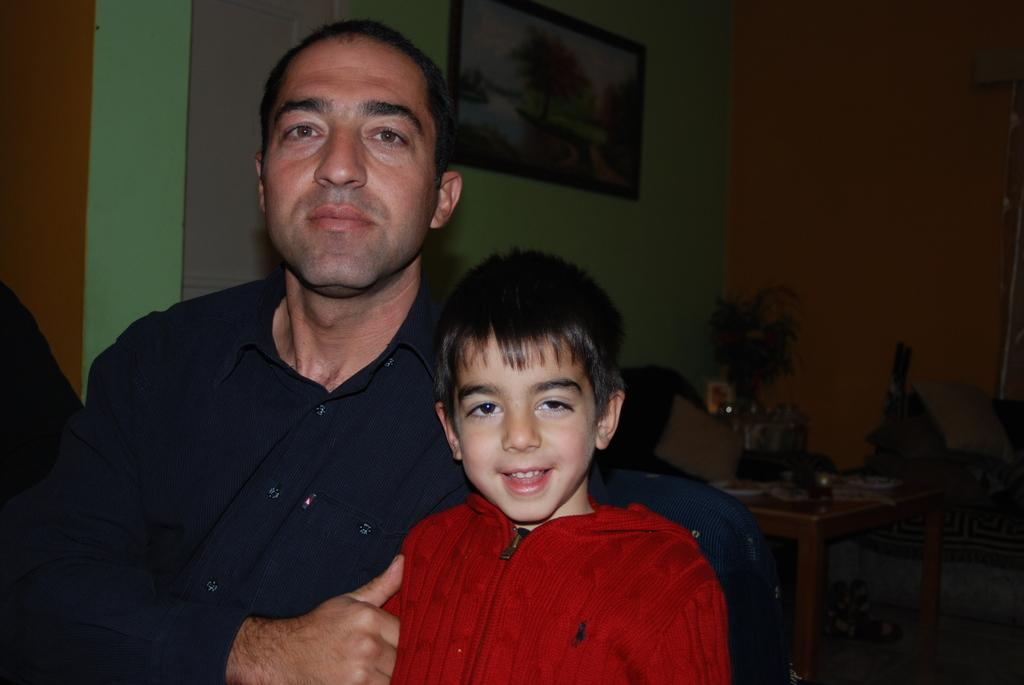How many people are in the image? There are 2 men in the image. What is present in the room where the men are located? There is a table, a wall, a frame, and a flower vase in the room. What type of hydrant is visible in the room? There is no hydrant present in the room; only a table, a wall, a frame, and a flower vase are visible. 